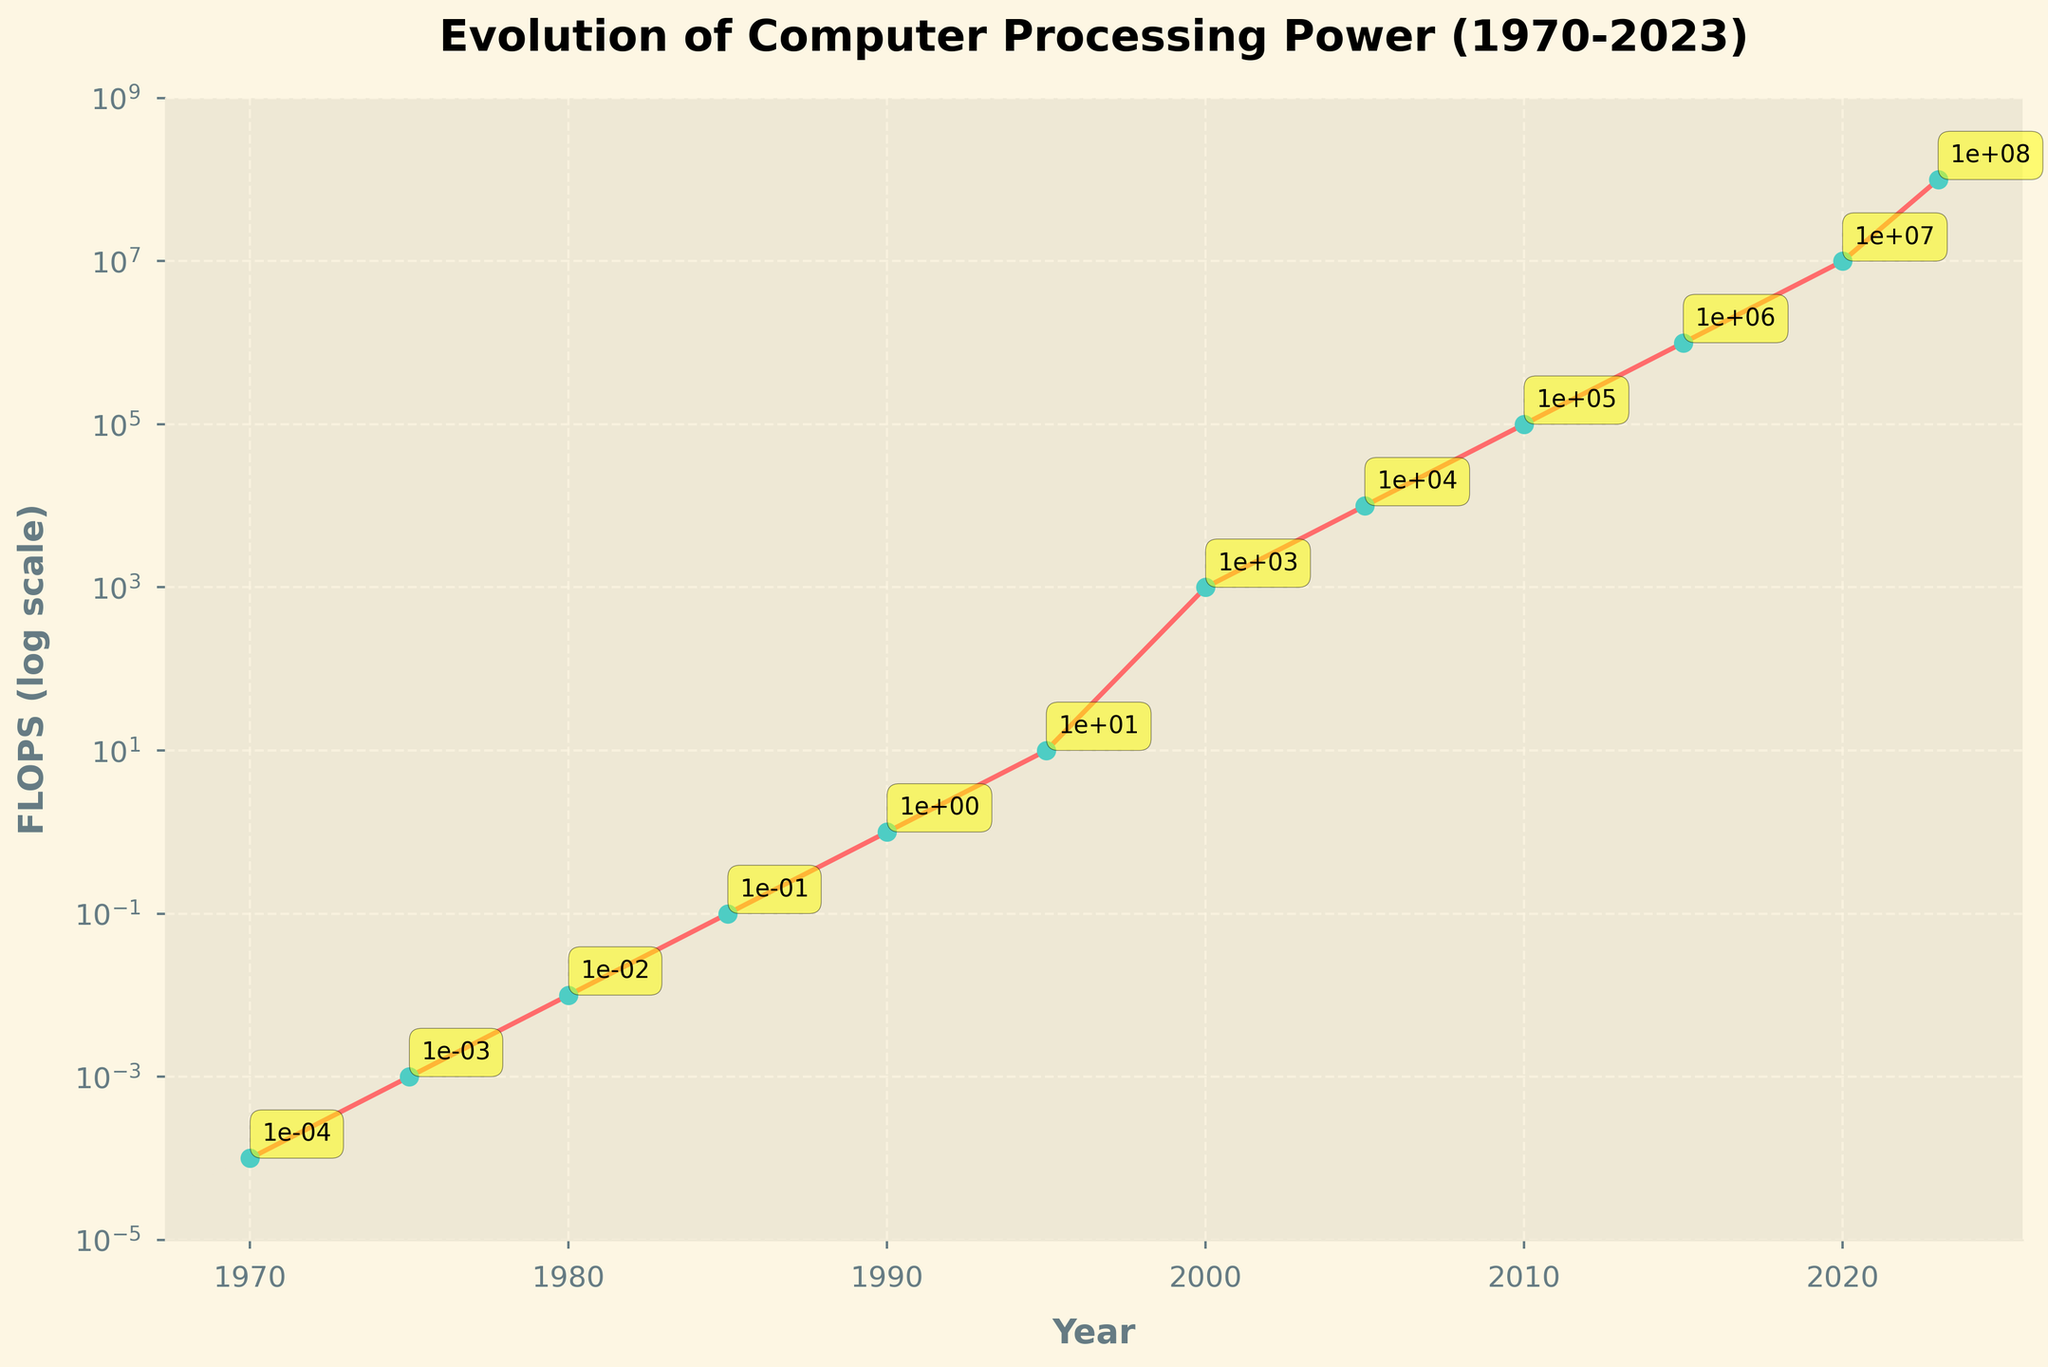What year did the processing power first exceed 1 FLOPS? Look at the y-axis to find the point where processing power exceeds 1 and note the corresponding year on the x-axis. The value exceeds 1 FLOPS in the year 1990.
Answer: 1990 By how many orders of magnitude did the processing power increase from 1970 to 2023? Compare the FLOPS value in 1970 (0.0001) to the FLOPS value in 2023 (100000000). Count the number of orders of magnitude (powers of 10) between these two values. From 1e-4 to 1e8, there are 12 orders of magnitude.
Answer: 12 How does the processing power in 2000 compare to that in 1995? Compare the FLOPS value in 2000 (1000) with the FLOPS value in 1995 (10). The processing power in 2000 is larger.
Answer: Greater Between which consecutive years did the largest jump in processing power occur? Identify the years with the largest difference in FLOPS values. The largest increase is between 1995 (10 FLOPS) and 2000 (1000 FLOPS).
Answer: 1995-2000 What is the average processing power in FLOPS for the years 1980, 1990, and 2000? Sum up the FLOPS values for the years 1980 (0.01), 1990 (1), and 2000 (1000). Divide by the number of years (3). (0.01 + 1 + 1000) / 3 = 333.67 FLOPS.
Answer: 333.67 What is the FLOPS value in 1985 written in scientific notation? Check the figure for the processing power in 1985 and write it in scientific notation. The value is 0.1 FLOPS, which is 1.0e-1 in scientific notation.
Answer: 1.0e-1 Does the processing power grow exponentially over the timeline? Examine the shape of the plot on a logarithmic scale. The values increase exponentially if the points form a straight line. The plot shows a consistent exponential increase.
Answer: Yes Which year shows the greatest absolute increase in processing power compared to the previous year? Find the year-by-year differences and locate the maximum difference. The largest increase is from 1995 to 2000 where the increase is 990 FLOPS (from 10 to 1000).
Answer: 2000 By what factor did the processing power increase from 2005 to 2010? Divide the FLOPS value in 2010 by the FLOPS value in 2005 (100000 / 10000). The factor is 10.
Answer: 10 What visual attributes indicate the exponential nature of the processing power's growth? Describe the plot's shape and features that highlight exponential growth. The processing power increases in a straight line on a logarithmic scale, with markers indicating steep growth through color differentiation and position.
Answer: Straight line on a log scale, steep growth 